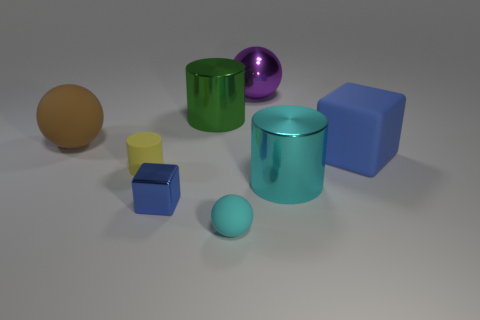What number of green things are the same shape as the yellow matte thing?
Offer a terse response. 1. Are the large blue object and the tiny object in front of the tiny blue cube made of the same material?
Make the answer very short. Yes. How many tiny brown matte cylinders are there?
Make the answer very short. 0. What is the size of the cyan matte ball that is to the left of the large cyan cylinder?
Provide a succinct answer. Small. How many blocks have the same size as the green thing?
Your answer should be very brief. 1. There is a cylinder that is on the right side of the rubber cylinder and to the left of the cyan cylinder; what material is it?
Ensure brevity in your answer.  Metal. What is the material of the cyan cylinder that is the same size as the brown ball?
Your answer should be very brief. Metal. There is a rubber sphere right of the blue object to the left of the blue cube right of the large purple sphere; what size is it?
Make the answer very short. Small. What size is the blue thing that is the same material as the green object?
Your response must be concise. Small. Do the green shiny cylinder and the metallic cylinder to the right of the large metallic sphere have the same size?
Make the answer very short. Yes. 